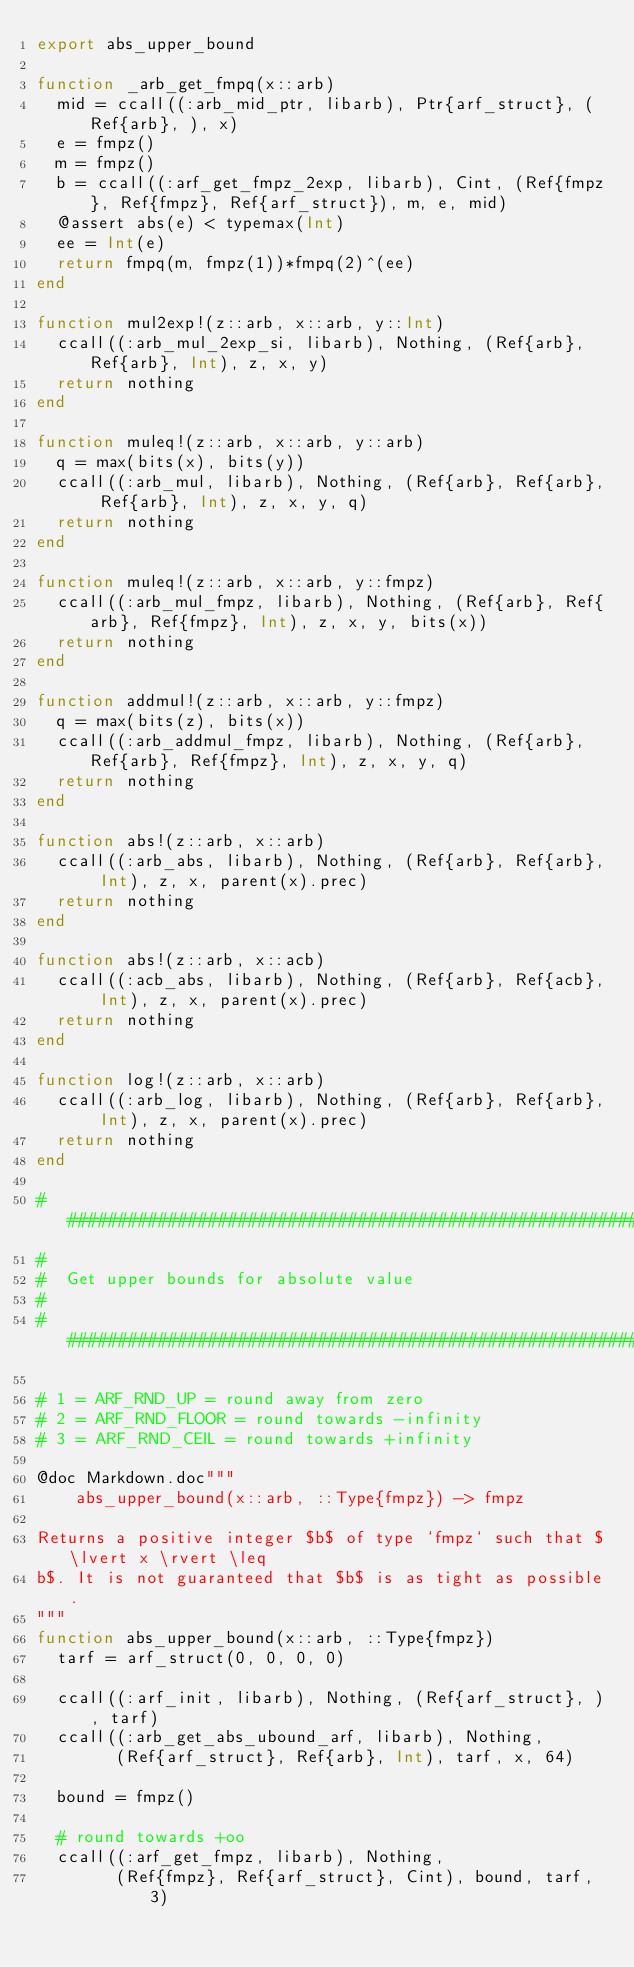Convert code to text. <code><loc_0><loc_0><loc_500><loc_500><_Julia_>export abs_upper_bound

function _arb_get_fmpq(x::arb)
  mid = ccall((:arb_mid_ptr, libarb), Ptr{arf_struct}, (Ref{arb}, ), x)
  e = fmpz()
  m = fmpz()
  b = ccall((:arf_get_fmpz_2exp, libarb), Cint, (Ref{fmpz}, Ref{fmpz}, Ref{arf_struct}), m, e, mid)
  @assert abs(e) < typemax(Int)
  ee = Int(e)
  return fmpq(m, fmpz(1))*fmpq(2)^(ee)
end

function mul2exp!(z::arb, x::arb, y::Int)
  ccall((:arb_mul_2exp_si, libarb), Nothing, (Ref{arb}, Ref{arb}, Int), z, x, y)
  return nothing
end

function muleq!(z::arb, x::arb, y::arb)
  q = max(bits(x), bits(y))
  ccall((:arb_mul, libarb), Nothing, (Ref{arb}, Ref{arb}, Ref{arb}, Int), z, x, y, q)
  return nothing
end

function muleq!(z::arb, x::arb, y::fmpz)
  ccall((:arb_mul_fmpz, libarb), Nothing, (Ref{arb}, Ref{arb}, Ref{fmpz}, Int), z, x, y, bits(x))
  return nothing
end

function addmul!(z::arb, x::arb, y::fmpz)
  q = max(bits(z), bits(x))
  ccall((:arb_addmul_fmpz, libarb), Nothing, (Ref{arb}, Ref{arb}, Ref{fmpz}, Int), z, x, y, q)
  return nothing
end

function abs!(z::arb, x::arb)
  ccall((:arb_abs, libarb), Nothing, (Ref{arb}, Ref{arb}, Int), z, x, parent(x).prec)
  return nothing
end

function abs!(z::arb, x::acb)
  ccall((:acb_abs, libarb), Nothing, (Ref{arb}, Ref{acb}, Int), z, x, parent(x).prec)
  return nothing
end

function log!(z::arb, x::arb)
  ccall((:arb_log, libarb), Nothing, (Ref{arb}, Ref{arb}, Int), z, x, parent(x).prec)
  return nothing
end

################################################################################
#
#  Get upper bounds for absolute value
#
################################################################################

# 1 = ARF_RND_UP = round away from zero
# 2 = ARF_RND_FLOOR = round towards -infinity
# 3 = ARF_RND_CEIL = round towards +infinity

@doc Markdown.doc"""
    abs_upper_bound(x::arb, ::Type{fmpz}) -> fmpz

Returns a positive integer $b$ of type `fmpz` such that $\lvert x \rvert \leq
b$. It is not guaranteed that $b$ is as tight as possible.
"""
function abs_upper_bound(x::arb, ::Type{fmpz})
  tarf = arf_struct(0, 0, 0, 0)

  ccall((:arf_init, libarb), Nothing, (Ref{arf_struct}, ), tarf)
  ccall((:arb_get_abs_ubound_arf, libarb), Nothing,
        (Ref{arf_struct}, Ref{arb}, Int), tarf, x, 64)

  bound = fmpz()

  # round towards +oo
  ccall((:arf_get_fmpz, libarb), Nothing,
        (Ref{fmpz}, Ref{arf_struct}, Cint), bound, tarf, 3)
</code> 